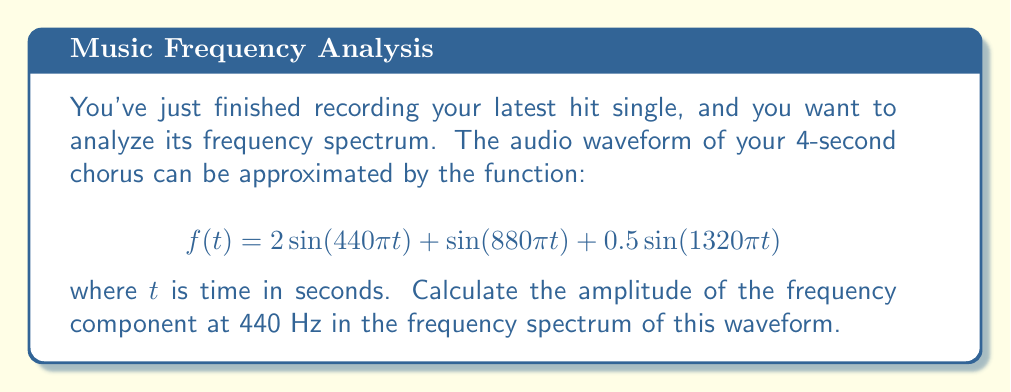Could you help me with this problem? To find the amplitude of the 440 Hz component in the frequency spectrum, we need to apply the Fourier transform to the given function. The Fourier transform of a continuous-time signal $f(t)$ is given by:

$$F(\omega) = \int_{-\infty}^{\infty} f(t) e^{-i\omega t} dt$$

where $\omega = 2\pi f$ and $f$ is the frequency in Hz.

For our waveform:

1) The first term, $2\sin(440\pi t)$, corresponds to a 220 Hz sine wave with amplitude 2.
2) The second term, $\sin(880\pi t)$, corresponds to a 440 Hz sine wave with amplitude 1.
3) The third term, $0.5\sin(1320\pi t)$, corresponds to a 660 Hz sine wave with amplitude 0.5.

The Fourier transform of a sine wave $A\sin(\omega_0 t)$ is:

$$F(\omega) = i\pi A[\delta(\omega-\omega_0) - \delta(\omega+\omega_0)]$$

where $\delta$ is the Dirac delta function.

For the 440 Hz component, we're interested in the second term of our waveform. Its Fourier transform is:

$$F(\omega) = i\pi [\delta(\omega-880\pi) - \delta(\omega+880\pi)]$$

The amplitude of this component in the frequency domain is the magnitude of the coefficient, which is $\pi$ or approximately 3.14159.

However, in practice, we often use the amplitude spectrum, which is twice this value for real signals. This accounts for the negative frequency component as well.
Answer: The amplitude of the 440 Hz component in the frequency spectrum is $2\pi \approx 6.28318$. 